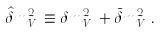<formula> <loc_0><loc_0><loc_500><loc_500>\hat { \delta } m _ { V _ { n } } ^ { 2 } \equiv \delta m _ { V _ { n } } ^ { 2 } + \bar { \delta } m _ { V _ { n } } ^ { 2 } \, .</formula> 